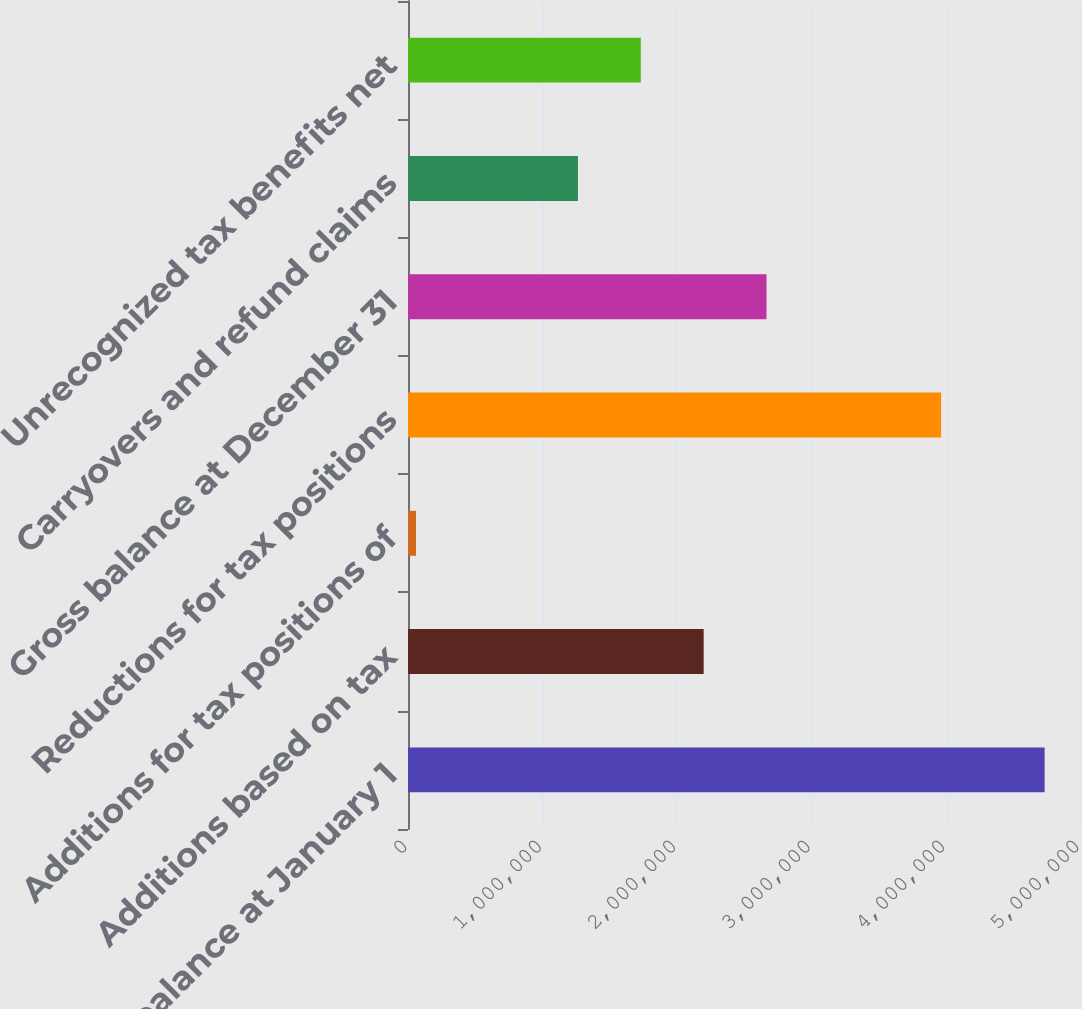Convert chart. <chart><loc_0><loc_0><loc_500><loc_500><bar_chart><fcel>Gross balance at January 1<fcel>Additions based on tax<fcel>Additions for tax positions of<fcel>Reductions for tax positions<fcel>Gross balance at December 31<fcel>Carryovers and refund claims<fcel>Unrecognized tax benefits net<nl><fcel>4.73678e+06<fcel>2.19988e+06<fcel>59815<fcel>3.96654e+06<fcel>2.66757e+06<fcel>1.26448e+06<fcel>1.73218e+06<nl></chart> 